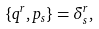Convert formula to latex. <formula><loc_0><loc_0><loc_500><loc_500>\{ q ^ { r } , p _ { s } \} = \delta _ { s } ^ { r } ,</formula> 